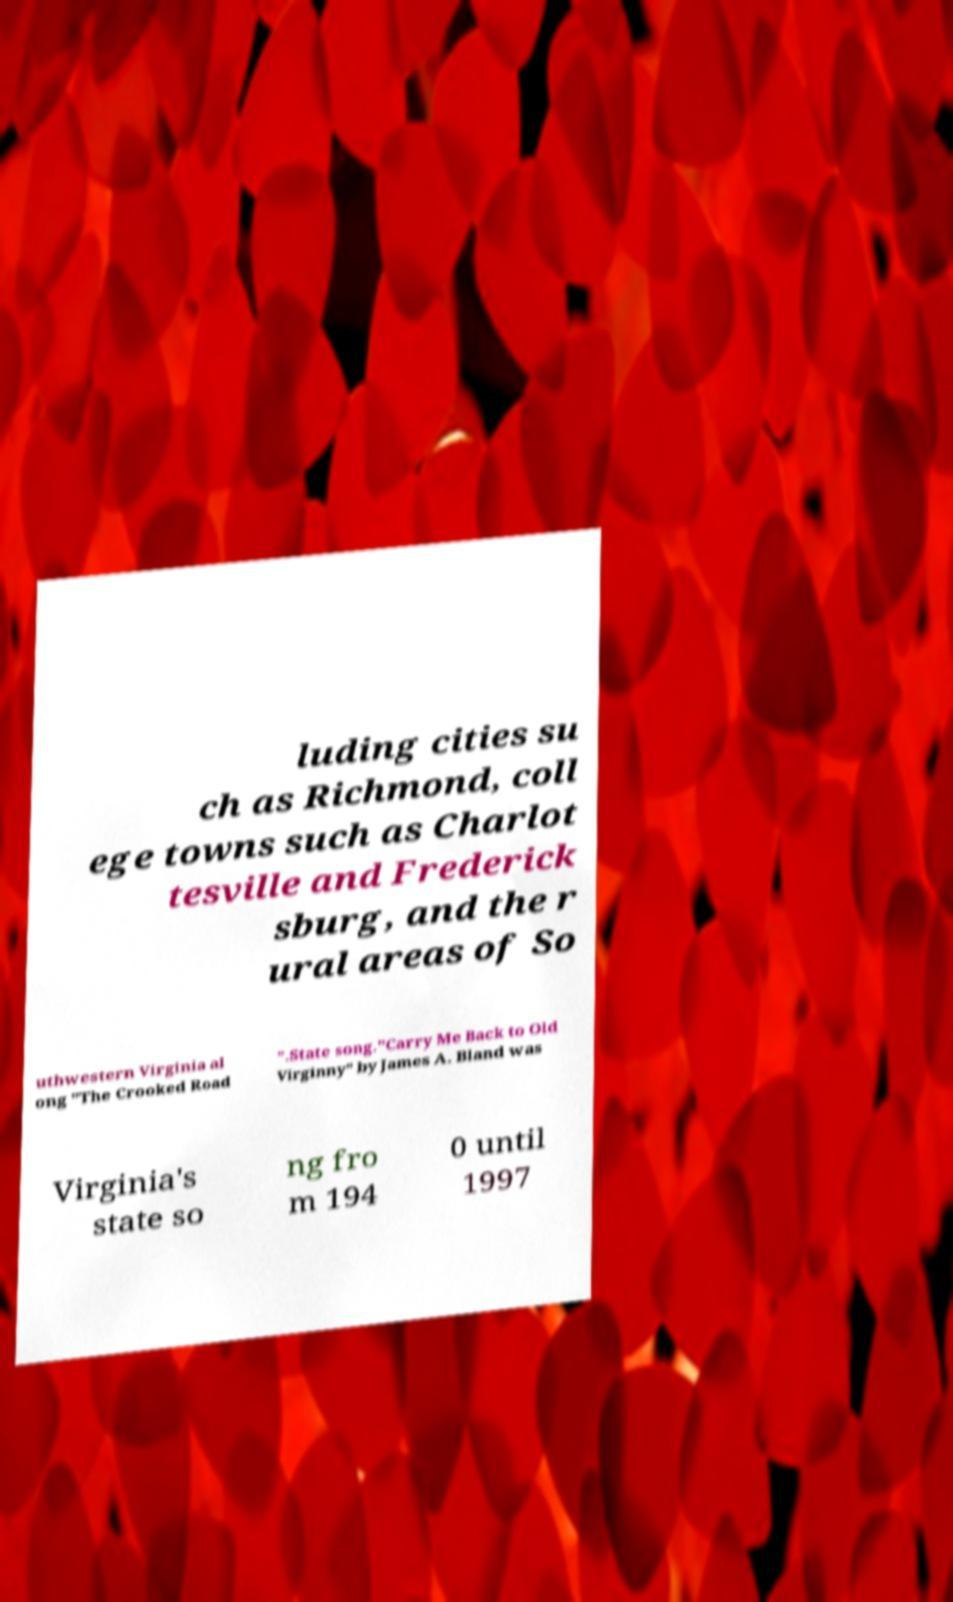There's text embedded in this image that I need extracted. Can you transcribe it verbatim? luding cities su ch as Richmond, coll ege towns such as Charlot tesville and Frederick sburg, and the r ural areas of So uthwestern Virginia al ong "The Crooked Road ”.State song."Carry Me Back to Old Virginny" by James A. Bland was Virginia's state so ng fro m 194 0 until 1997 